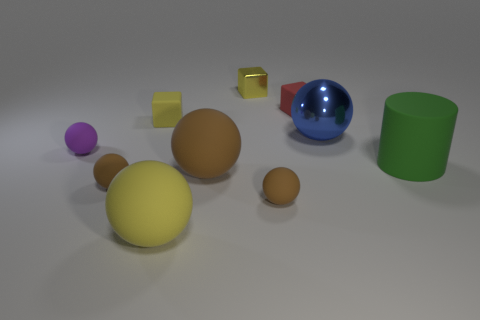Subtract all yellow balls. How many balls are left? 5 Subtract all red cubes. How many cubes are left? 2 Subtract all cylinders. How many objects are left? 9 Subtract all big brown metal things. Subtract all small yellow rubber blocks. How many objects are left? 9 Add 7 large green matte cylinders. How many large green matte cylinders are left? 8 Add 8 tiny metallic cubes. How many tiny metallic cubes exist? 9 Subtract 0 yellow cylinders. How many objects are left? 10 Subtract 1 cubes. How many cubes are left? 2 Subtract all red cubes. Subtract all gray balls. How many cubes are left? 2 Subtract all green blocks. How many yellow spheres are left? 1 